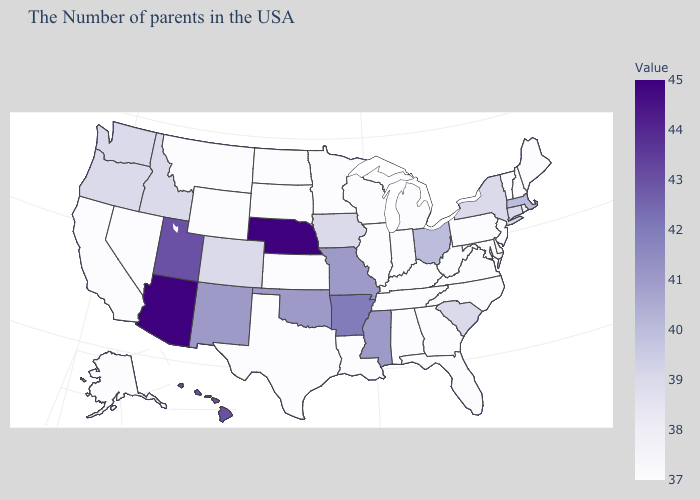Which states have the lowest value in the USA?
Quick response, please. Maine, New Hampshire, Vermont, New Jersey, Delaware, Maryland, Pennsylvania, Virginia, North Carolina, West Virginia, Florida, Georgia, Michigan, Kentucky, Indiana, Alabama, Tennessee, Wisconsin, Illinois, Louisiana, Minnesota, Kansas, Texas, South Dakota, North Dakota, Wyoming, Montana, Nevada, California, Alaska. Which states have the lowest value in the USA?
Short answer required. Maine, New Hampshire, Vermont, New Jersey, Delaware, Maryland, Pennsylvania, Virginia, North Carolina, West Virginia, Florida, Georgia, Michigan, Kentucky, Indiana, Alabama, Tennessee, Wisconsin, Illinois, Louisiana, Minnesota, Kansas, Texas, South Dakota, North Dakota, Wyoming, Montana, Nevada, California, Alaska. Does Arizona have the highest value in the USA?
Give a very brief answer. Yes. Among the states that border Georgia , which have the lowest value?
Short answer required. North Carolina, Florida, Alabama, Tennessee. Among the states that border California , which have the lowest value?
Write a very short answer. Nevada. 